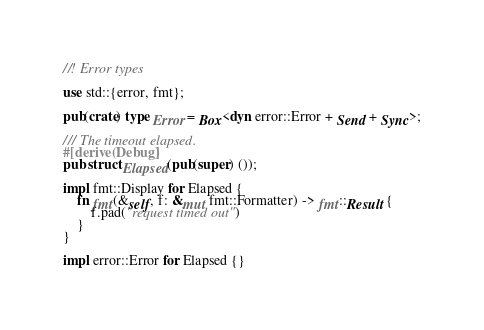Convert code to text. <code><loc_0><loc_0><loc_500><loc_500><_Rust_>//! Error types

use std::{error, fmt};

pub(crate) type Error = Box<dyn error::Error + Send + Sync>;

/// The timeout elapsed.
#[derive(Debug)]
pub struct Elapsed(pub(super) ());

impl fmt::Display for Elapsed {
    fn fmt(&self, f: &mut fmt::Formatter) -> fmt::Result {
        f.pad("request timed out")
    }
}

impl error::Error for Elapsed {}
</code> 